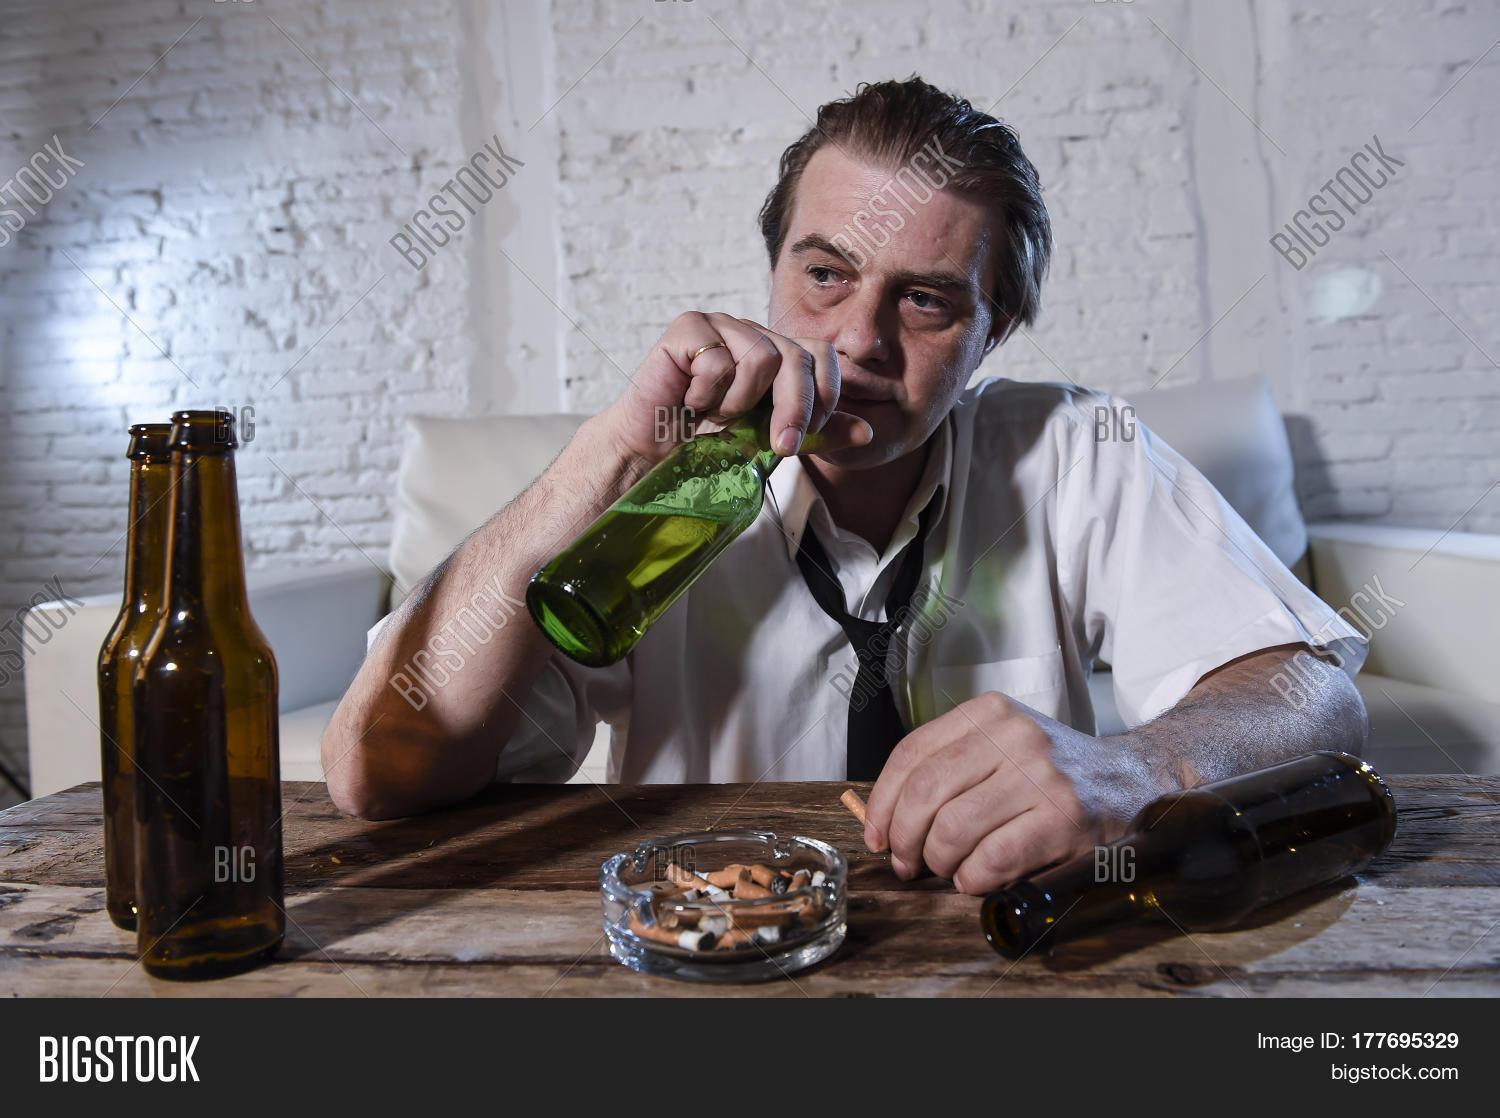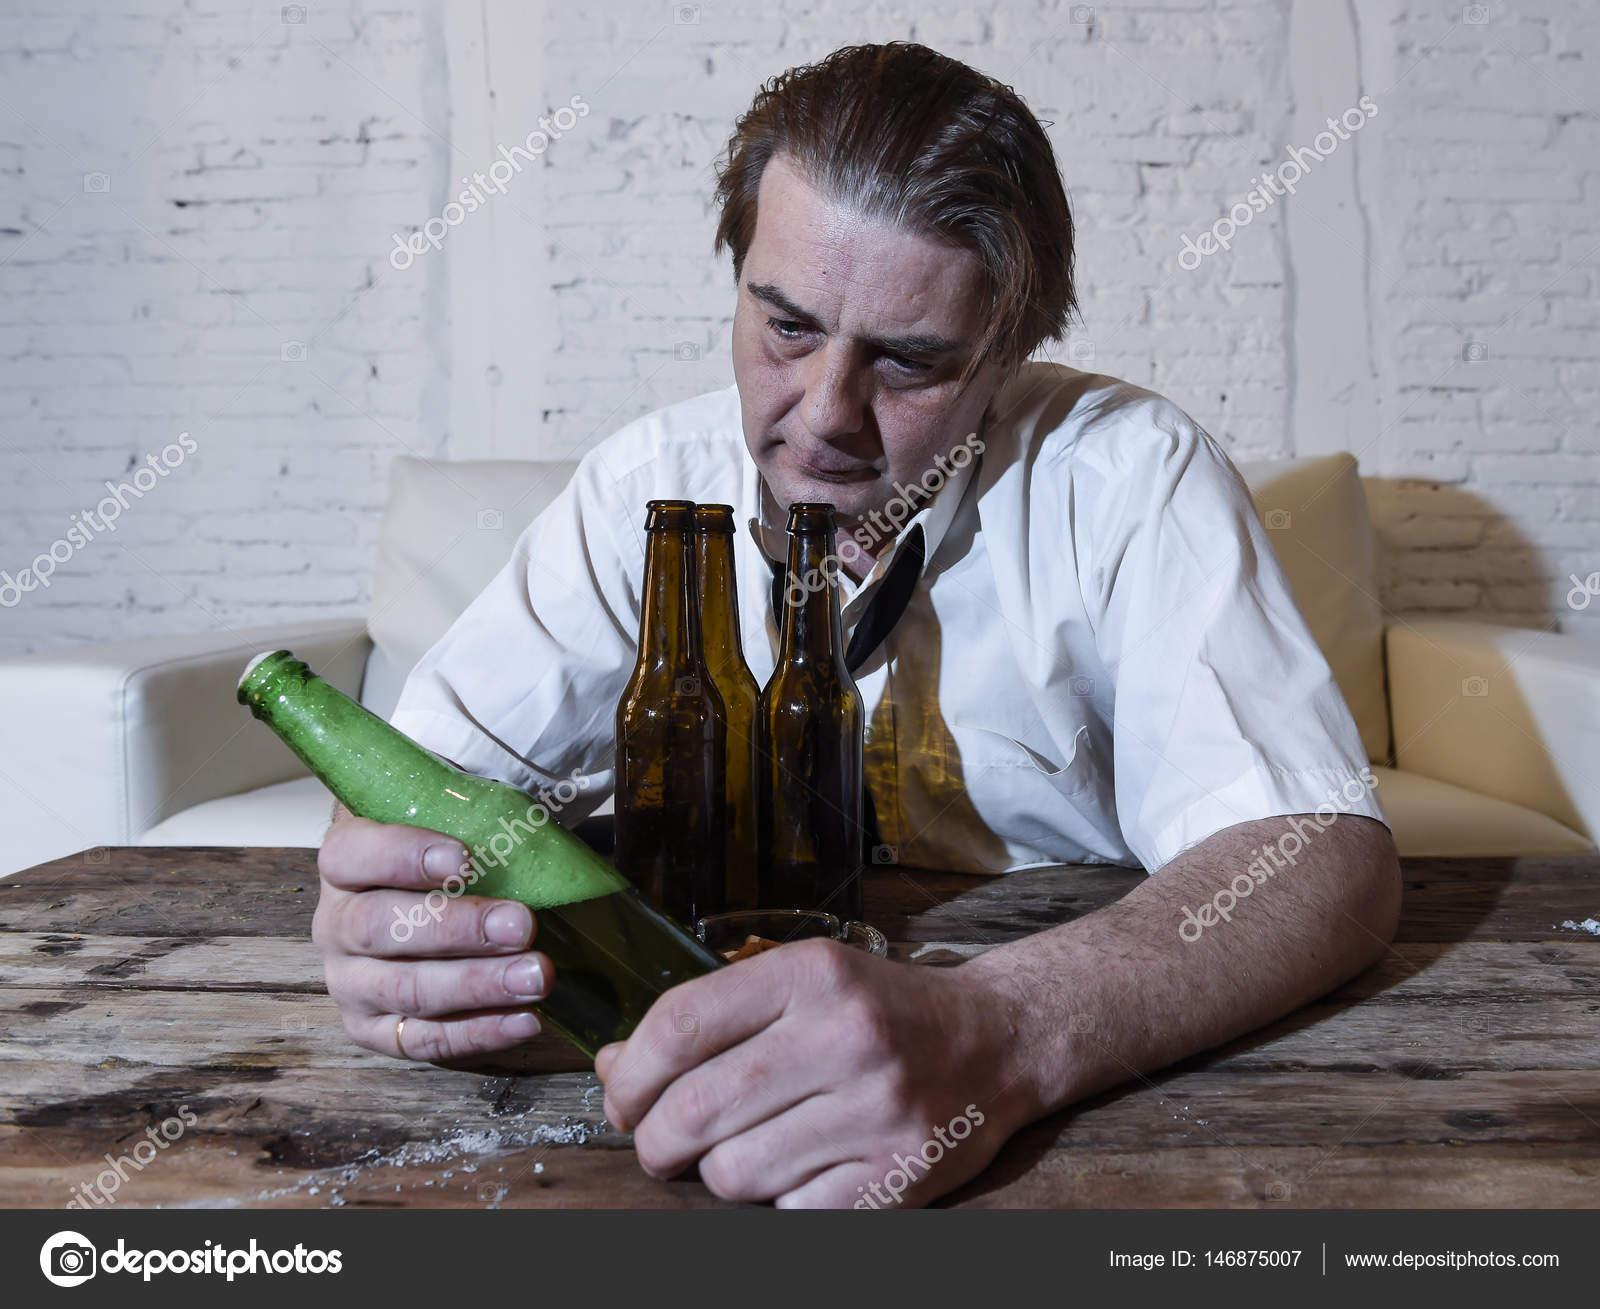The first image is the image on the left, the second image is the image on the right. Analyze the images presented: Is the assertion "The man is drinking his beer in the left image." valid? Answer yes or no. Yes. 